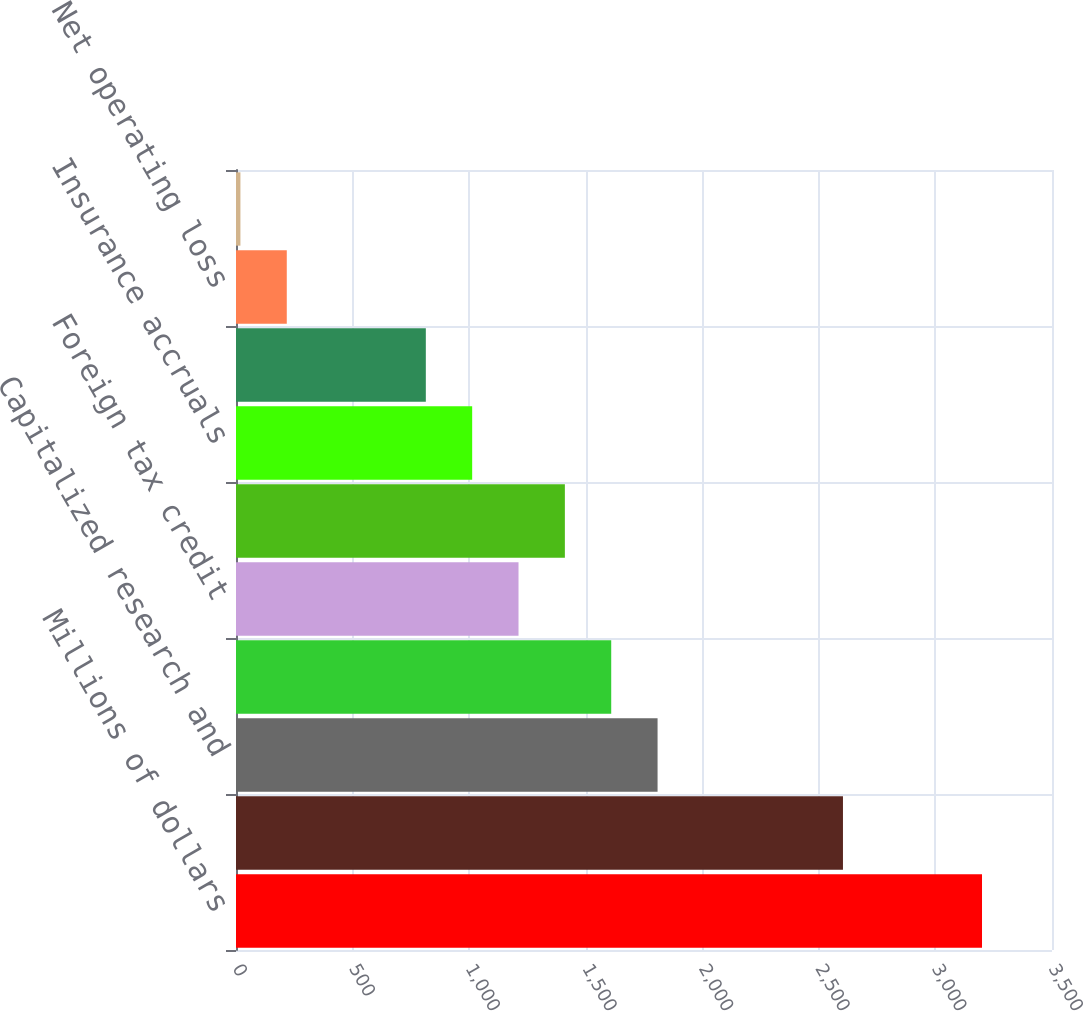Convert chart. <chart><loc_0><loc_0><loc_500><loc_500><bar_chart><fcel>Millions of dollars<fcel>Employee compensation and<fcel>Capitalized research and<fcel>Accrued liabilities<fcel>Foreign tax credit<fcel>Inventory<fcel>Insurance accruals<fcel>Software revenue recognition<fcel>Net operating loss<fcel>Alternative minimum tax credit<nl><fcel>3199.8<fcel>2603.4<fcel>1808.2<fcel>1609.4<fcel>1211.8<fcel>1410.6<fcel>1013<fcel>814.2<fcel>217.8<fcel>19<nl></chart> 